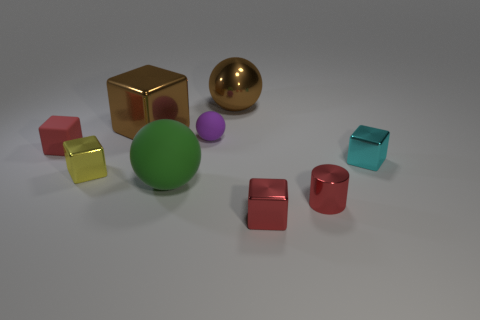If you had to guess, what purpose do these objects serve? Based on the simplistic yet diverse shapes and colors, these objects could serve an educational purpose, perhaps as part of a learning kit for children to teach about geometry, colors, or spatial awareness. 